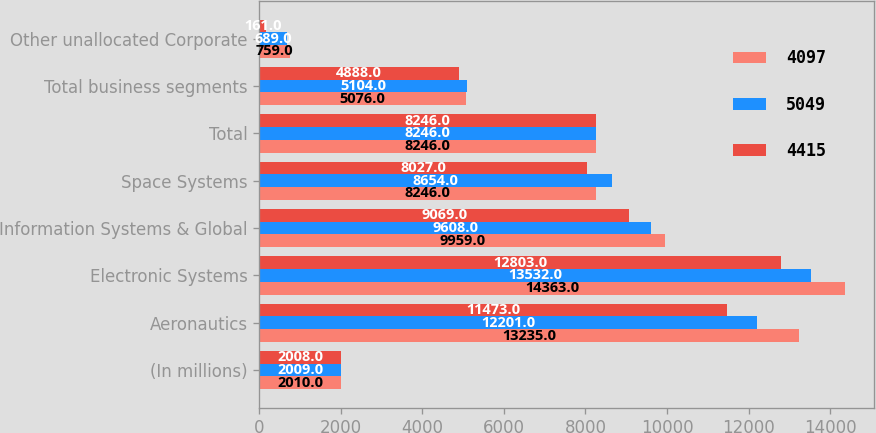Convert chart to OTSL. <chart><loc_0><loc_0><loc_500><loc_500><stacked_bar_chart><ecel><fcel>(In millions)<fcel>Aeronautics<fcel>Electronic Systems<fcel>Information Systems & Global<fcel>Space Systems<fcel>Total<fcel>Total business segments<fcel>Other unallocated Corporate<nl><fcel>4097<fcel>2010<fcel>13235<fcel>14363<fcel>9959<fcel>8246<fcel>8246<fcel>5076<fcel>759<nl><fcel>5049<fcel>2009<fcel>12201<fcel>13532<fcel>9608<fcel>8654<fcel>8246<fcel>5104<fcel>689<nl><fcel>4415<fcel>2008<fcel>11473<fcel>12803<fcel>9069<fcel>8027<fcel>8246<fcel>4888<fcel>161<nl></chart> 